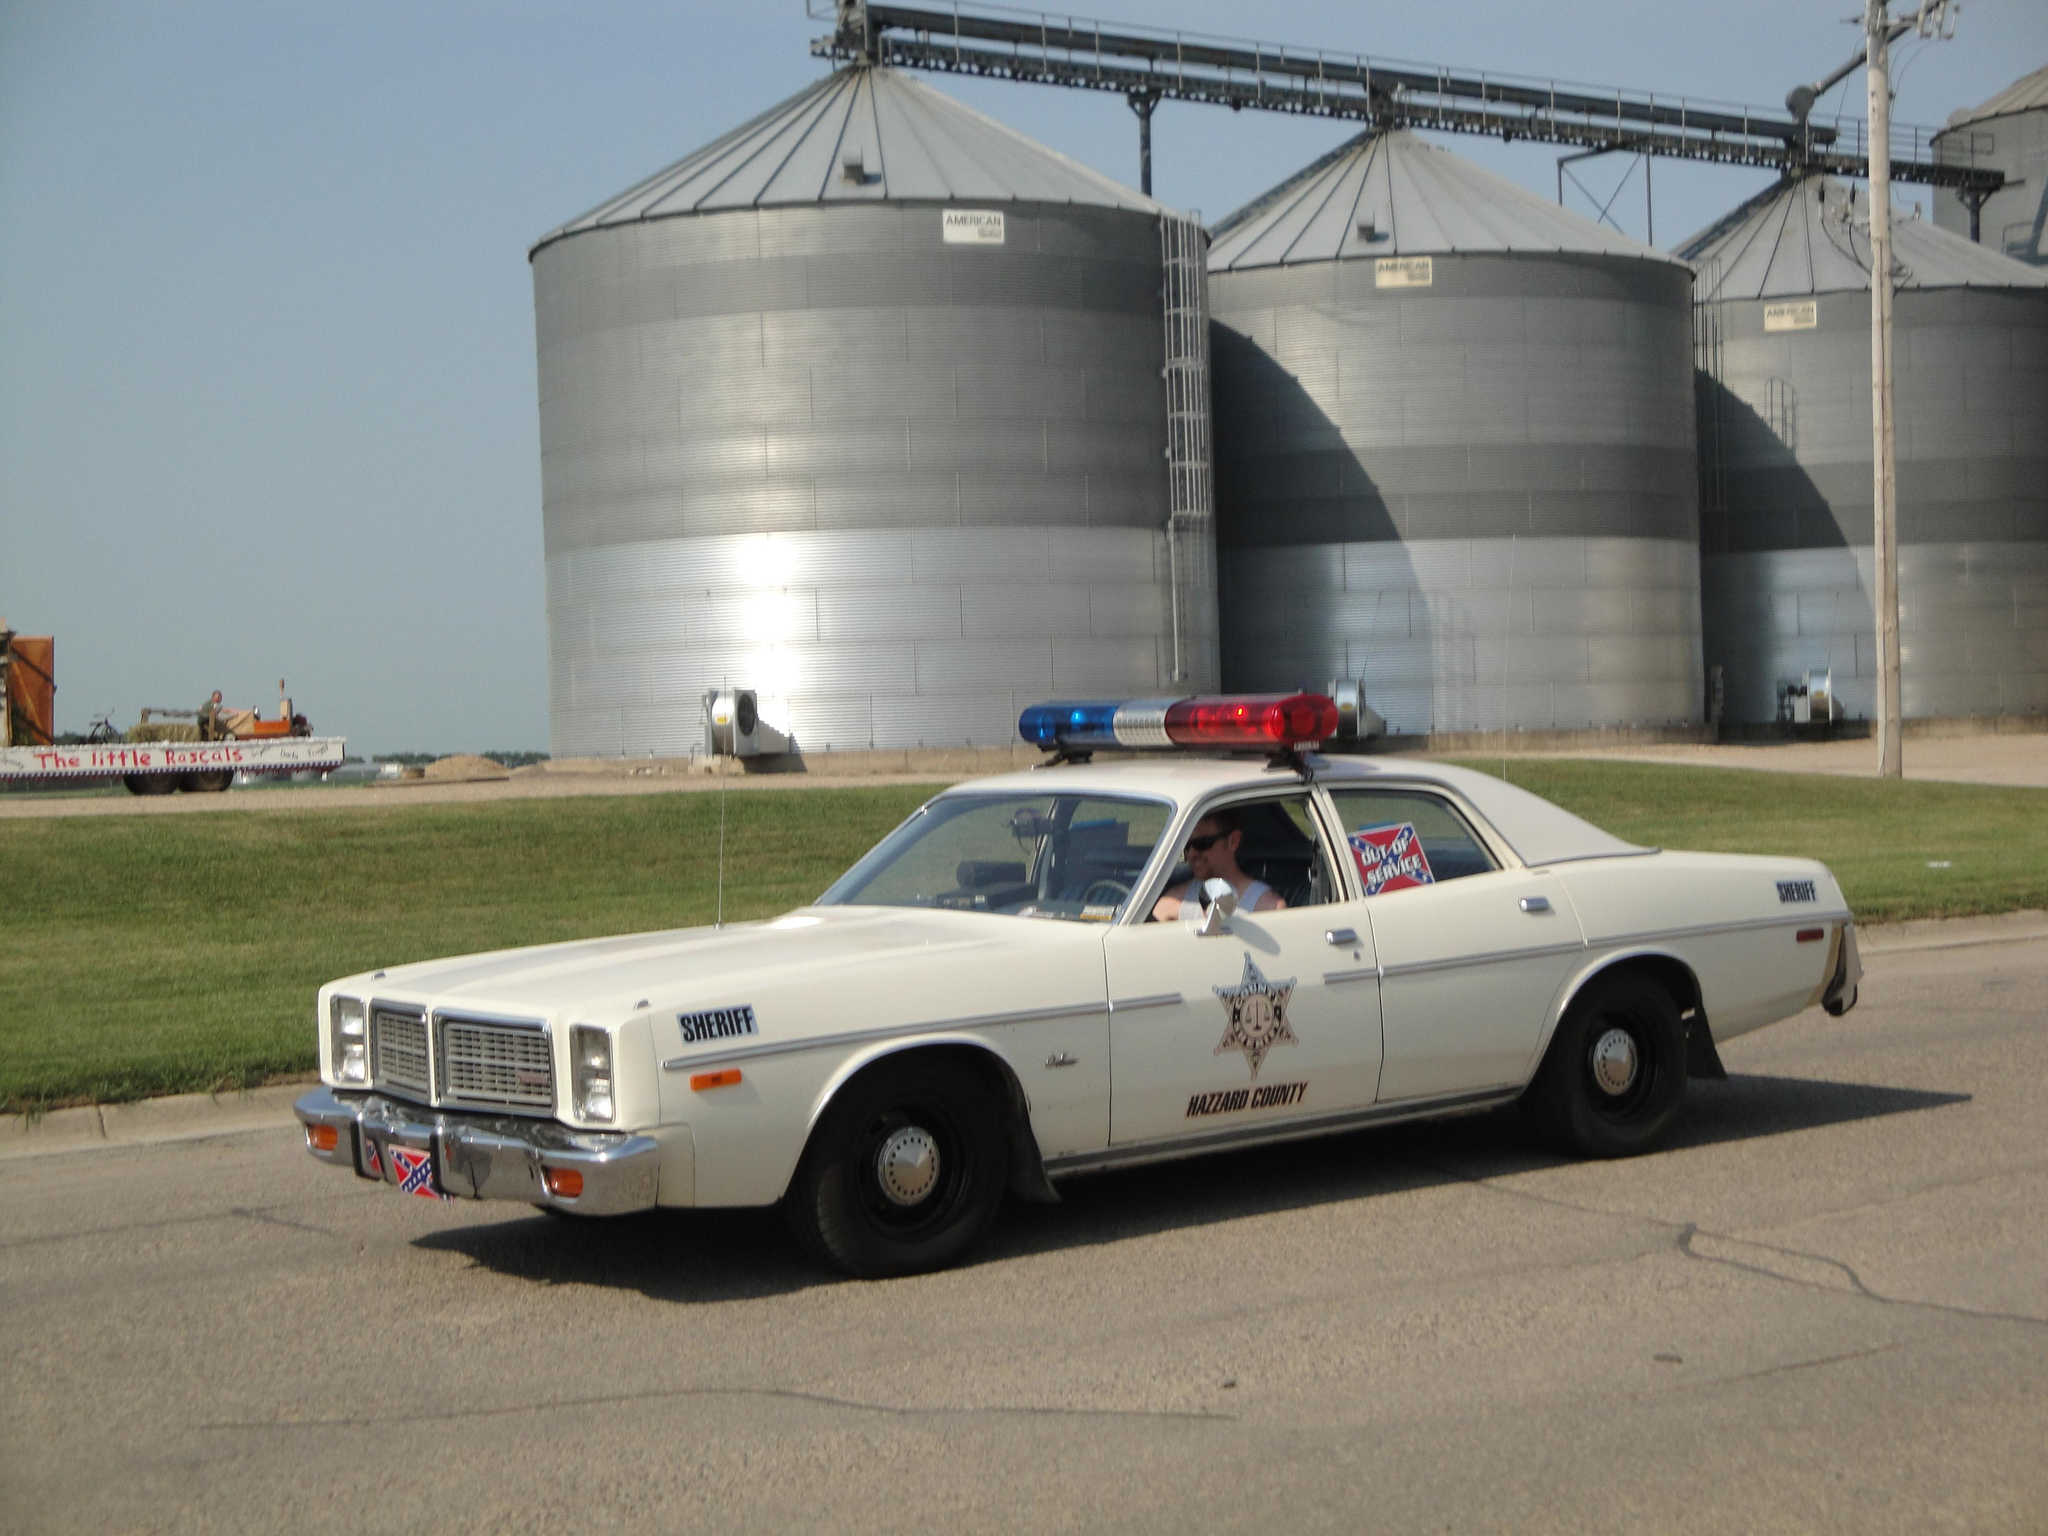What is the person in the image doing? There is a person sitting inside a car in the image. Where is the car located? The car is on the road in the image. What type of vegetation can be seen in the image? There is grass visible in the image. What is the tall, vertical object in the image? There is a pole in the image. What type of objects can be seen in the image besides the car and the pole? There are containers and other objects in the image. What is visible in the background of the image? The sky is visible in the background of the image. What type of corn is being used for arithmetic calculations in the image? There is no corn or arithmetic calculations present in the image. What type of cloth is draped over the containers in the image? There is no cloth draped over the containers in the image. 